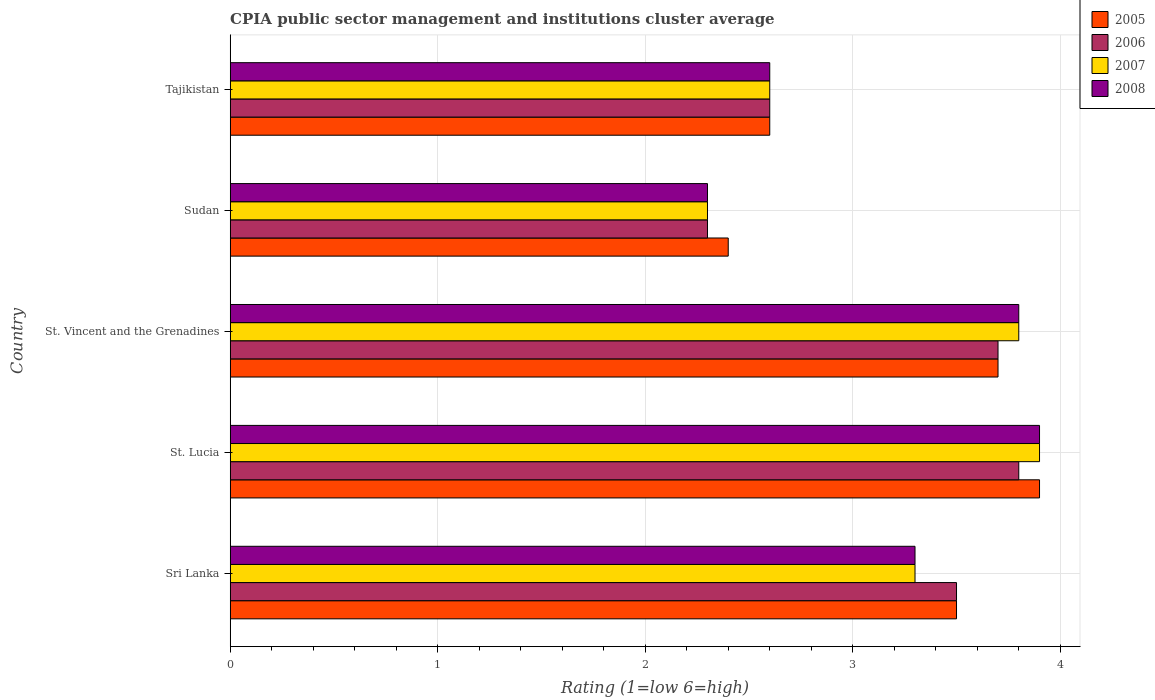How many groups of bars are there?
Your answer should be very brief. 5. How many bars are there on the 5th tick from the bottom?
Your answer should be very brief. 4. What is the label of the 1st group of bars from the top?
Keep it short and to the point. Tajikistan. What is the CPIA rating in 2005 in St. Lucia?
Offer a terse response. 3.9. Across all countries, what is the minimum CPIA rating in 2007?
Give a very brief answer. 2.3. In which country was the CPIA rating in 2006 maximum?
Provide a succinct answer. St. Lucia. In which country was the CPIA rating in 2007 minimum?
Your answer should be very brief. Sudan. What is the total CPIA rating in 2006 in the graph?
Make the answer very short. 15.9. What is the difference between the CPIA rating in 2008 in Sri Lanka and that in St. Lucia?
Offer a very short reply. -0.6. What is the difference between the CPIA rating in 2008 in St. Lucia and the CPIA rating in 2005 in St. Vincent and the Grenadines?
Make the answer very short. 0.2. What is the average CPIA rating in 2006 per country?
Provide a short and direct response. 3.18. What is the difference between the CPIA rating in 2007 and CPIA rating in 2006 in Tajikistan?
Keep it short and to the point. 0. In how many countries, is the CPIA rating in 2007 greater than 0.6000000000000001 ?
Your response must be concise. 5. What is the ratio of the CPIA rating in 2006 in St. Lucia to that in St. Vincent and the Grenadines?
Provide a succinct answer. 1.03. Is the CPIA rating in 2006 in St. Lucia less than that in St. Vincent and the Grenadines?
Provide a short and direct response. No. Is the difference between the CPIA rating in 2007 in St. Lucia and St. Vincent and the Grenadines greater than the difference between the CPIA rating in 2006 in St. Lucia and St. Vincent and the Grenadines?
Ensure brevity in your answer.  Yes. What is the difference between the highest and the second highest CPIA rating in 2008?
Provide a short and direct response. 0.1. Is it the case that in every country, the sum of the CPIA rating in 2007 and CPIA rating in 2006 is greater than the sum of CPIA rating in 2008 and CPIA rating in 2005?
Your answer should be very brief. No. How many bars are there?
Your answer should be compact. 20. What is the difference between two consecutive major ticks on the X-axis?
Provide a short and direct response. 1. Does the graph contain any zero values?
Offer a terse response. No. Does the graph contain grids?
Provide a succinct answer. Yes. How many legend labels are there?
Keep it short and to the point. 4. How are the legend labels stacked?
Ensure brevity in your answer.  Vertical. What is the title of the graph?
Provide a succinct answer. CPIA public sector management and institutions cluster average. What is the label or title of the X-axis?
Give a very brief answer. Rating (1=low 6=high). What is the Rating (1=low 6=high) in 2008 in Sri Lanka?
Give a very brief answer. 3.3. What is the Rating (1=low 6=high) of 2006 in St. Lucia?
Ensure brevity in your answer.  3.8. What is the Rating (1=low 6=high) in 2007 in St. Lucia?
Provide a succinct answer. 3.9. What is the Rating (1=low 6=high) of 2007 in St. Vincent and the Grenadines?
Provide a succinct answer. 3.8. What is the Rating (1=low 6=high) in 2005 in Sudan?
Your response must be concise. 2.4. What is the Rating (1=low 6=high) in 2006 in Sudan?
Provide a short and direct response. 2.3. What is the Rating (1=low 6=high) of 2007 in Sudan?
Keep it short and to the point. 2.3. What is the Rating (1=low 6=high) of 2005 in Tajikistan?
Keep it short and to the point. 2.6. What is the Rating (1=low 6=high) of 2006 in Tajikistan?
Provide a succinct answer. 2.6. What is the Rating (1=low 6=high) of 2007 in Tajikistan?
Give a very brief answer. 2.6. Across all countries, what is the maximum Rating (1=low 6=high) in 2007?
Your answer should be compact. 3.9. Across all countries, what is the minimum Rating (1=low 6=high) of 2005?
Provide a short and direct response. 2.4. Across all countries, what is the minimum Rating (1=low 6=high) of 2006?
Make the answer very short. 2.3. Across all countries, what is the minimum Rating (1=low 6=high) of 2007?
Provide a succinct answer. 2.3. What is the total Rating (1=low 6=high) in 2005 in the graph?
Give a very brief answer. 16.1. What is the total Rating (1=low 6=high) of 2007 in the graph?
Provide a succinct answer. 15.9. What is the total Rating (1=low 6=high) of 2008 in the graph?
Offer a very short reply. 15.9. What is the difference between the Rating (1=low 6=high) of 2007 in Sri Lanka and that in St. Lucia?
Provide a short and direct response. -0.6. What is the difference between the Rating (1=low 6=high) in 2006 in Sri Lanka and that in St. Vincent and the Grenadines?
Give a very brief answer. -0.2. What is the difference between the Rating (1=low 6=high) of 2007 in Sri Lanka and that in St. Vincent and the Grenadines?
Provide a succinct answer. -0.5. What is the difference between the Rating (1=low 6=high) in 2008 in Sri Lanka and that in St. Vincent and the Grenadines?
Ensure brevity in your answer.  -0.5. What is the difference between the Rating (1=low 6=high) in 2005 in Sri Lanka and that in Sudan?
Make the answer very short. 1.1. What is the difference between the Rating (1=low 6=high) of 2006 in Sri Lanka and that in Sudan?
Ensure brevity in your answer.  1.2. What is the difference between the Rating (1=low 6=high) of 2007 in Sri Lanka and that in Sudan?
Make the answer very short. 1. What is the difference between the Rating (1=low 6=high) of 2008 in Sri Lanka and that in Sudan?
Provide a succinct answer. 1. What is the difference between the Rating (1=low 6=high) of 2005 in Sri Lanka and that in Tajikistan?
Offer a very short reply. 0.9. What is the difference between the Rating (1=low 6=high) of 2006 in Sri Lanka and that in Tajikistan?
Provide a succinct answer. 0.9. What is the difference between the Rating (1=low 6=high) in 2008 in Sri Lanka and that in Tajikistan?
Provide a succinct answer. 0.7. What is the difference between the Rating (1=low 6=high) in 2008 in St. Lucia and that in St. Vincent and the Grenadines?
Your response must be concise. 0.1. What is the difference between the Rating (1=low 6=high) in 2006 in St. Lucia and that in Sudan?
Make the answer very short. 1.5. What is the difference between the Rating (1=low 6=high) of 2007 in St. Lucia and that in Sudan?
Make the answer very short. 1.6. What is the difference between the Rating (1=low 6=high) in 2008 in St. Lucia and that in Sudan?
Ensure brevity in your answer.  1.6. What is the difference between the Rating (1=low 6=high) of 2005 in St. Lucia and that in Tajikistan?
Ensure brevity in your answer.  1.3. What is the difference between the Rating (1=low 6=high) of 2007 in St. Lucia and that in Tajikistan?
Give a very brief answer. 1.3. What is the difference between the Rating (1=low 6=high) in 2008 in St. Lucia and that in Tajikistan?
Your answer should be compact. 1.3. What is the difference between the Rating (1=low 6=high) in 2005 in St. Vincent and the Grenadines and that in Sudan?
Your response must be concise. 1.3. What is the difference between the Rating (1=low 6=high) of 2007 in St. Vincent and the Grenadines and that in Sudan?
Your answer should be very brief. 1.5. What is the difference between the Rating (1=low 6=high) of 2006 in St. Vincent and the Grenadines and that in Tajikistan?
Give a very brief answer. 1.1. What is the difference between the Rating (1=low 6=high) in 2007 in St. Vincent and the Grenadines and that in Tajikistan?
Your response must be concise. 1.2. What is the difference between the Rating (1=low 6=high) of 2008 in Sudan and that in Tajikistan?
Keep it short and to the point. -0.3. What is the difference between the Rating (1=low 6=high) in 2005 in Sri Lanka and the Rating (1=low 6=high) in 2006 in St. Lucia?
Offer a very short reply. -0.3. What is the difference between the Rating (1=low 6=high) of 2005 in Sri Lanka and the Rating (1=low 6=high) of 2007 in St. Lucia?
Ensure brevity in your answer.  -0.4. What is the difference between the Rating (1=low 6=high) in 2005 in Sri Lanka and the Rating (1=low 6=high) in 2008 in St. Lucia?
Make the answer very short. -0.4. What is the difference between the Rating (1=low 6=high) in 2006 in Sri Lanka and the Rating (1=low 6=high) in 2007 in St. Lucia?
Your answer should be very brief. -0.4. What is the difference between the Rating (1=low 6=high) in 2005 in Sri Lanka and the Rating (1=low 6=high) in 2007 in St. Vincent and the Grenadines?
Give a very brief answer. -0.3. What is the difference between the Rating (1=low 6=high) in 2005 in Sri Lanka and the Rating (1=low 6=high) in 2008 in St. Vincent and the Grenadines?
Your answer should be very brief. -0.3. What is the difference between the Rating (1=low 6=high) in 2006 in Sri Lanka and the Rating (1=low 6=high) in 2007 in St. Vincent and the Grenadines?
Your answer should be compact. -0.3. What is the difference between the Rating (1=low 6=high) in 2006 in Sri Lanka and the Rating (1=low 6=high) in 2008 in St. Vincent and the Grenadines?
Ensure brevity in your answer.  -0.3. What is the difference between the Rating (1=low 6=high) of 2007 in Sri Lanka and the Rating (1=low 6=high) of 2008 in St. Vincent and the Grenadines?
Offer a terse response. -0.5. What is the difference between the Rating (1=low 6=high) in 2005 in Sri Lanka and the Rating (1=low 6=high) in 2006 in Sudan?
Make the answer very short. 1.2. What is the difference between the Rating (1=low 6=high) of 2005 in Sri Lanka and the Rating (1=low 6=high) of 2007 in Sudan?
Keep it short and to the point. 1.2. What is the difference between the Rating (1=low 6=high) of 2006 in Sri Lanka and the Rating (1=low 6=high) of 2008 in Sudan?
Make the answer very short. 1.2. What is the difference between the Rating (1=low 6=high) in 2007 in Sri Lanka and the Rating (1=low 6=high) in 2008 in Sudan?
Provide a short and direct response. 1. What is the difference between the Rating (1=low 6=high) in 2005 in Sri Lanka and the Rating (1=low 6=high) in 2008 in Tajikistan?
Offer a very short reply. 0.9. What is the difference between the Rating (1=low 6=high) in 2006 in Sri Lanka and the Rating (1=low 6=high) in 2007 in Tajikistan?
Provide a short and direct response. 0.9. What is the difference between the Rating (1=low 6=high) in 2005 in St. Lucia and the Rating (1=low 6=high) in 2006 in St. Vincent and the Grenadines?
Give a very brief answer. 0.2. What is the difference between the Rating (1=low 6=high) of 2006 in St. Lucia and the Rating (1=low 6=high) of 2008 in St. Vincent and the Grenadines?
Ensure brevity in your answer.  0. What is the difference between the Rating (1=low 6=high) of 2007 in St. Lucia and the Rating (1=low 6=high) of 2008 in St. Vincent and the Grenadines?
Make the answer very short. 0.1. What is the difference between the Rating (1=low 6=high) in 2005 in St. Lucia and the Rating (1=low 6=high) in 2007 in Sudan?
Keep it short and to the point. 1.6. What is the difference between the Rating (1=low 6=high) in 2006 in St. Lucia and the Rating (1=low 6=high) in 2008 in Sudan?
Provide a short and direct response. 1.5. What is the difference between the Rating (1=low 6=high) in 2007 in St. Lucia and the Rating (1=low 6=high) in 2008 in Sudan?
Keep it short and to the point. 1.6. What is the difference between the Rating (1=low 6=high) of 2005 in St. Lucia and the Rating (1=low 6=high) of 2006 in Tajikistan?
Your answer should be compact. 1.3. What is the difference between the Rating (1=low 6=high) of 2005 in St. Lucia and the Rating (1=low 6=high) of 2007 in Tajikistan?
Your answer should be very brief. 1.3. What is the difference between the Rating (1=low 6=high) of 2005 in St. Lucia and the Rating (1=low 6=high) of 2008 in Tajikistan?
Offer a very short reply. 1.3. What is the difference between the Rating (1=low 6=high) of 2006 in St. Lucia and the Rating (1=low 6=high) of 2007 in Tajikistan?
Your answer should be compact. 1.2. What is the difference between the Rating (1=low 6=high) in 2005 in St. Vincent and the Grenadines and the Rating (1=low 6=high) in 2006 in Sudan?
Give a very brief answer. 1.4. What is the difference between the Rating (1=low 6=high) of 2005 in St. Vincent and the Grenadines and the Rating (1=low 6=high) of 2007 in Sudan?
Keep it short and to the point. 1.4. What is the difference between the Rating (1=low 6=high) of 2005 in St. Vincent and the Grenadines and the Rating (1=low 6=high) of 2008 in Sudan?
Provide a succinct answer. 1.4. What is the difference between the Rating (1=low 6=high) of 2006 in St. Vincent and the Grenadines and the Rating (1=low 6=high) of 2008 in Sudan?
Ensure brevity in your answer.  1.4. What is the difference between the Rating (1=low 6=high) of 2007 in St. Vincent and the Grenadines and the Rating (1=low 6=high) of 2008 in Sudan?
Provide a short and direct response. 1.5. What is the difference between the Rating (1=low 6=high) in 2006 in St. Vincent and the Grenadines and the Rating (1=low 6=high) in 2007 in Tajikistan?
Your answer should be compact. 1.1. What is the difference between the Rating (1=low 6=high) in 2006 in St. Vincent and the Grenadines and the Rating (1=low 6=high) in 2008 in Tajikistan?
Give a very brief answer. 1.1. What is the difference between the Rating (1=low 6=high) in 2005 in Sudan and the Rating (1=low 6=high) in 2007 in Tajikistan?
Your answer should be compact. -0.2. What is the difference between the Rating (1=low 6=high) of 2005 in Sudan and the Rating (1=low 6=high) of 2008 in Tajikistan?
Make the answer very short. -0.2. What is the difference between the Rating (1=low 6=high) of 2007 in Sudan and the Rating (1=low 6=high) of 2008 in Tajikistan?
Your answer should be very brief. -0.3. What is the average Rating (1=low 6=high) in 2005 per country?
Provide a succinct answer. 3.22. What is the average Rating (1=low 6=high) of 2006 per country?
Offer a very short reply. 3.18. What is the average Rating (1=low 6=high) in 2007 per country?
Make the answer very short. 3.18. What is the average Rating (1=low 6=high) of 2008 per country?
Offer a very short reply. 3.18. What is the difference between the Rating (1=low 6=high) of 2005 and Rating (1=low 6=high) of 2006 in Sri Lanka?
Give a very brief answer. 0. What is the difference between the Rating (1=low 6=high) of 2005 and Rating (1=low 6=high) of 2007 in Sri Lanka?
Your answer should be compact. 0.2. What is the difference between the Rating (1=low 6=high) in 2006 and Rating (1=low 6=high) in 2007 in Sri Lanka?
Offer a terse response. 0.2. What is the difference between the Rating (1=low 6=high) in 2007 and Rating (1=low 6=high) in 2008 in Sri Lanka?
Make the answer very short. 0. What is the difference between the Rating (1=low 6=high) in 2005 and Rating (1=low 6=high) in 2006 in St. Lucia?
Ensure brevity in your answer.  0.1. What is the difference between the Rating (1=low 6=high) of 2005 and Rating (1=low 6=high) of 2007 in St. Lucia?
Provide a succinct answer. 0. What is the difference between the Rating (1=low 6=high) of 2005 and Rating (1=low 6=high) of 2008 in St. Lucia?
Offer a terse response. 0. What is the difference between the Rating (1=low 6=high) of 2006 and Rating (1=low 6=high) of 2008 in St. Lucia?
Provide a succinct answer. -0.1. What is the difference between the Rating (1=low 6=high) of 2005 and Rating (1=low 6=high) of 2007 in St. Vincent and the Grenadines?
Keep it short and to the point. -0.1. What is the difference between the Rating (1=low 6=high) of 2005 and Rating (1=low 6=high) of 2006 in Sudan?
Give a very brief answer. 0.1. What is the difference between the Rating (1=low 6=high) in 2005 and Rating (1=low 6=high) in 2008 in Sudan?
Keep it short and to the point. 0.1. What is the difference between the Rating (1=low 6=high) of 2006 and Rating (1=low 6=high) of 2008 in Sudan?
Keep it short and to the point. 0. What is the difference between the Rating (1=low 6=high) of 2007 and Rating (1=low 6=high) of 2008 in Sudan?
Give a very brief answer. 0. What is the difference between the Rating (1=low 6=high) of 2005 and Rating (1=low 6=high) of 2006 in Tajikistan?
Your response must be concise. 0. What is the difference between the Rating (1=low 6=high) of 2005 and Rating (1=low 6=high) of 2007 in Tajikistan?
Offer a terse response. 0. What is the difference between the Rating (1=low 6=high) of 2005 and Rating (1=low 6=high) of 2008 in Tajikistan?
Your response must be concise. 0. What is the difference between the Rating (1=low 6=high) of 2006 and Rating (1=low 6=high) of 2007 in Tajikistan?
Give a very brief answer. 0. What is the difference between the Rating (1=low 6=high) in 2006 and Rating (1=low 6=high) in 2008 in Tajikistan?
Provide a succinct answer. 0. What is the ratio of the Rating (1=low 6=high) in 2005 in Sri Lanka to that in St. Lucia?
Your answer should be very brief. 0.9. What is the ratio of the Rating (1=low 6=high) in 2006 in Sri Lanka to that in St. Lucia?
Your response must be concise. 0.92. What is the ratio of the Rating (1=low 6=high) of 2007 in Sri Lanka to that in St. Lucia?
Your response must be concise. 0.85. What is the ratio of the Rating (1=low 6=high) in 2008 in Sri Lanka to that in St. Lucia?
Your answer should be compact. 0.85. What is the ratio of the Rating (1=low 6=high) in 2005 in Sri Lanka to that in St. Vincent and the Grenadines?
Your answer should be compact. 0.95. What is the ratio of the Rating (1=low 6=high) in 2006 in Sri Lanka to that in St. Vincent and the Grenadines?
Make the answer very short. 0.95. What is the ratio of the Rating (1=low 6=high) of 2007 in Sri Lanka to that in St. Vincent and the Grenadines?
Your response must be concise. 0.87. What is the ratio of the Rating (1=low 6=high) in 2008 in Sri Lanka to that in St. Vincent and the Grenadines?
Give a very brief answer. 0.87. What is the ratio of the Rating (1=low 6=high) in 2005 in Sri Lanka to that in Sudan?
Provide a succinct answer. 1.46. What is the ratio of the Rating (1=low 6=high) in 2006 in Sri Lanka to that in Sudan?
Offer a terse response. 1.52. What is the ratio of the Rating (1=low 6=high) in 2007 in Sri Lanka to that in Sudan?
Your answer should be compact. 1.43. What is the ratio of the Rating (1=low 6=high) in 2008 in Sri Lanka to that in Sudan?
Provide a succinct answer. 1.43. What is the ratio of the Rating (1=low 6=high) of 2005 in Sri Lanka to that in Tajikistan?
Make the answer very short. 1.35. What is the ratio of the Rating (1=low 6=high) in 2006 in Sri Lanka to that in Tajikistan?
Make the answer very short. 1.35. What is the ratio of the Rating (1=low 6=high) in 2007 in Sri Lanka to that in Tajikistan?
Keep it short and to the point. 1.27. What is the ratio of the Rating (1=low 6=high) of 2008 in Sri Lanka to that in Tajikistan?
Ensure brevity in your answer.  1.27. What is the ratio of the Rating (1=low 6=high) of 2005 in St. Lucia to that in St. Vincent and the Grenadines?
Ensure brevity in your answer.  1.05. What is the ratio of the Rating (1=low 6=high) of 2007 in St. Lucia to that in St. Vincent and the Grenadines?
Provide a succinct answer. 1.03. What is the ratio of the Rating (1=low 6=high) of 2008 in St. Lucia to that in St. Vincent and the Grenadines?
Your answer should be very brief. 1.03. What is the ratio of the Rating (1=low 6=high) in 2005 in St. Lucia to that in Sudan?
Your response must be concise. 1.62. What is the ratio of the Rating (1=low 6=high) of 2006 in St. Lucia to that in Sudan?
Keep it short and to the point. 1.65. What is the ratio of the Rating (1=low 6=high) in 2007 in St. Lucia to that in Sudan?
Your answer should be very brief. 1.7. What is the ratio of the Rating (1=low 6=high) in 2008 in St. Lucia to that in Sudan?
Make the answer very short. 1.7. What is the ratio of the Rating (1=low 6=high) in 2005 in St. Lucia to that in Tajikistan?
Keep it short and to the point. 1.5. What is the ratio of the Rating (1=low 6=high) in 2006 in St. Lucia to that in Tajikistan?
Keep it short and to the point. 1.46. What is the ratio of the Rating (1=low 6=high) in 2008 in St. Lucia to that in Tajikistan?
Your answer should be very brief. 1.5. What is the ratio of the Rating (1=low 6=high) of 2005 in St. Vincent and the Grenadines to that in Sudan?
Offer a very short reply. 1.54. What is the ratio of the Rating (1=low 6=high) of 2006 in St. Vincent and the Grenadines to that in Sudan?
Provide a short and direct response. 1.61. What is the ratio of the Rating (1=low 6=high) in 2007 in St. Vincent and the Grenadines to that in Sudan?
Give a very brief answer. 1.65. What is the ratio of the Rating (1=low 6=high) in 2008 in St. Vincent and the Grenadines to that in Sudan?
Offer a terse response. 1.65. What is the ratio of the Rating (1=low 6=high) in 2005 in St. Vincent and the Grenadines to that in Tajikistan?
Ensure brevity in your answer.  1.42. What is the ratio of the Rating (1=low 6=high) of 2006 in St. Vincent and the Grenadines to that in Tajikistan?
Provide a short and direct response. 1.42. What is the ratio of the Rating (1=low 6=high) of 2007 in St. Vincent and the Grenadines to that in Tajikistan?
Your answer should be very brief. 1.46. What is the ratio of the Rating (1=low 6=high) in 2008 in St. Vincent and the Grenadines to that in Tajikistan?
Give a very brief answer. 1.46. What is the ratio of the Rating (1=low 6=high) in 2006 in Sudan to that in Tajikistan?
Offer a very short reply. 0.88. What is the ratio of the Rating (1=low 6=high) of 2007 in Sudan to that in Tajikistan?
Give a very brief answer. 0.88. What is the ratio of the Rating (1=low 6=high) in 2008 in Sudan to that in Tajikistan?
Make the answer very short. 0.88. What is the difference between the highest and the second highest Rating (1=low 6=high) of 2005?
Ensure brevity in your answer.  0.2. What is the difference between the highest and the second highest Rating (1=low 6=high) in 2007?
Make the answer very short. 0.1. What is the difference between the highest and the second highest Rating (1=low 6=high) of 2008?
Your answer should be compact. 0.1. What is the difference between the highest and the lowest Rating (1=low 6=high) in 2005?
Ensure brevity in your answer.  1.5. What is the difference between the highest and the lowest Rating (1=low 6=high) in 2008?
Give a very brief answer. 1.6. 